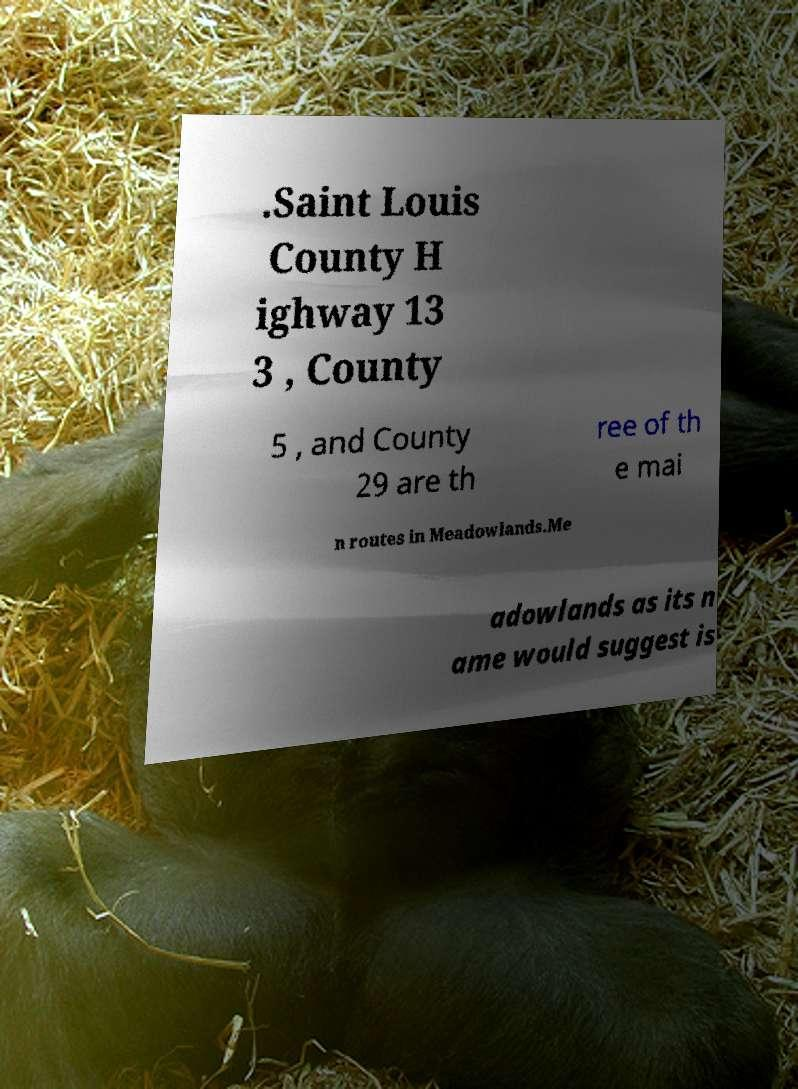Can you read and provide the text displayed in the image?This photo seems to have some interesting text. Can you extract and type it out for me? .Saint Louis County H ighway 13 3 , County 5 , and County 29 are th ree of th e mai n routes in Meadowlands.Me adowlands as its n ame would suggest is 